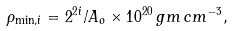Convert formula to latex. <formula><loc_0><loc_0><loc_500><loc_500>\rho _ { \min , i } = 2 ^ { 2 i } / A _ { o } \times 1 0 ^ { 2 0 } \, g m \, c m ^ { - 3 } ,</formula> 